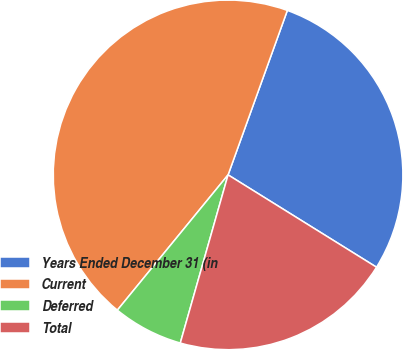Convert chart. <chart><loc_0><loc_0><loc_500><loc_500><pie_chart><fcel>Years Ended December 31 (in<fcel>Current<fcel>Deferred<fcel>Total<nl><fcel>28.35%<fcel>44.59%<fcel>6.51%<fcel>20.55%<nl></chart> 